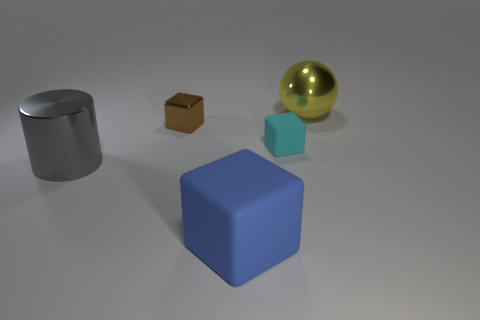Subtract all tiny cyan cubes. How many cubes are left? 2 Add 4 tiny gray metallic things. How many objects exist? 9 Subtract all blue blocks. How many blocks are left? 2 Subtract all balls. How many objects are left? 4 Subtract all brown objects. Subtract all green metallic cylinders. How many objects are left? 4 Add 5 blue things. How many blue things are left? 6 Add 4 yellow metal things. How many yellow metal things exist? 5 Subtract 1 blue cubes. How many objects are left? 4 Subtract 1 spheres. How many spheres are left? 0 Subtract all blue balls. Subtract all yellow cylinders. How many balls are left? 1 